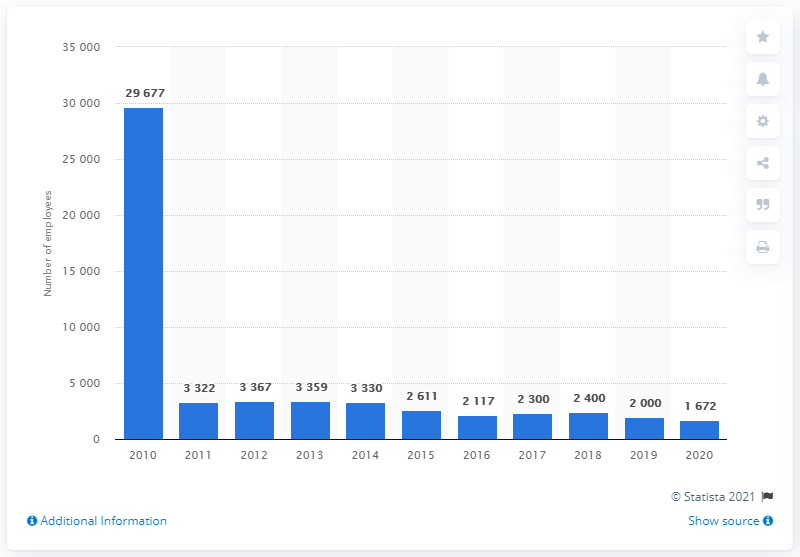Mention a couple of crucial points in this snapshot. In 2011, Marathon Oil Corporation separated its downstream business. 